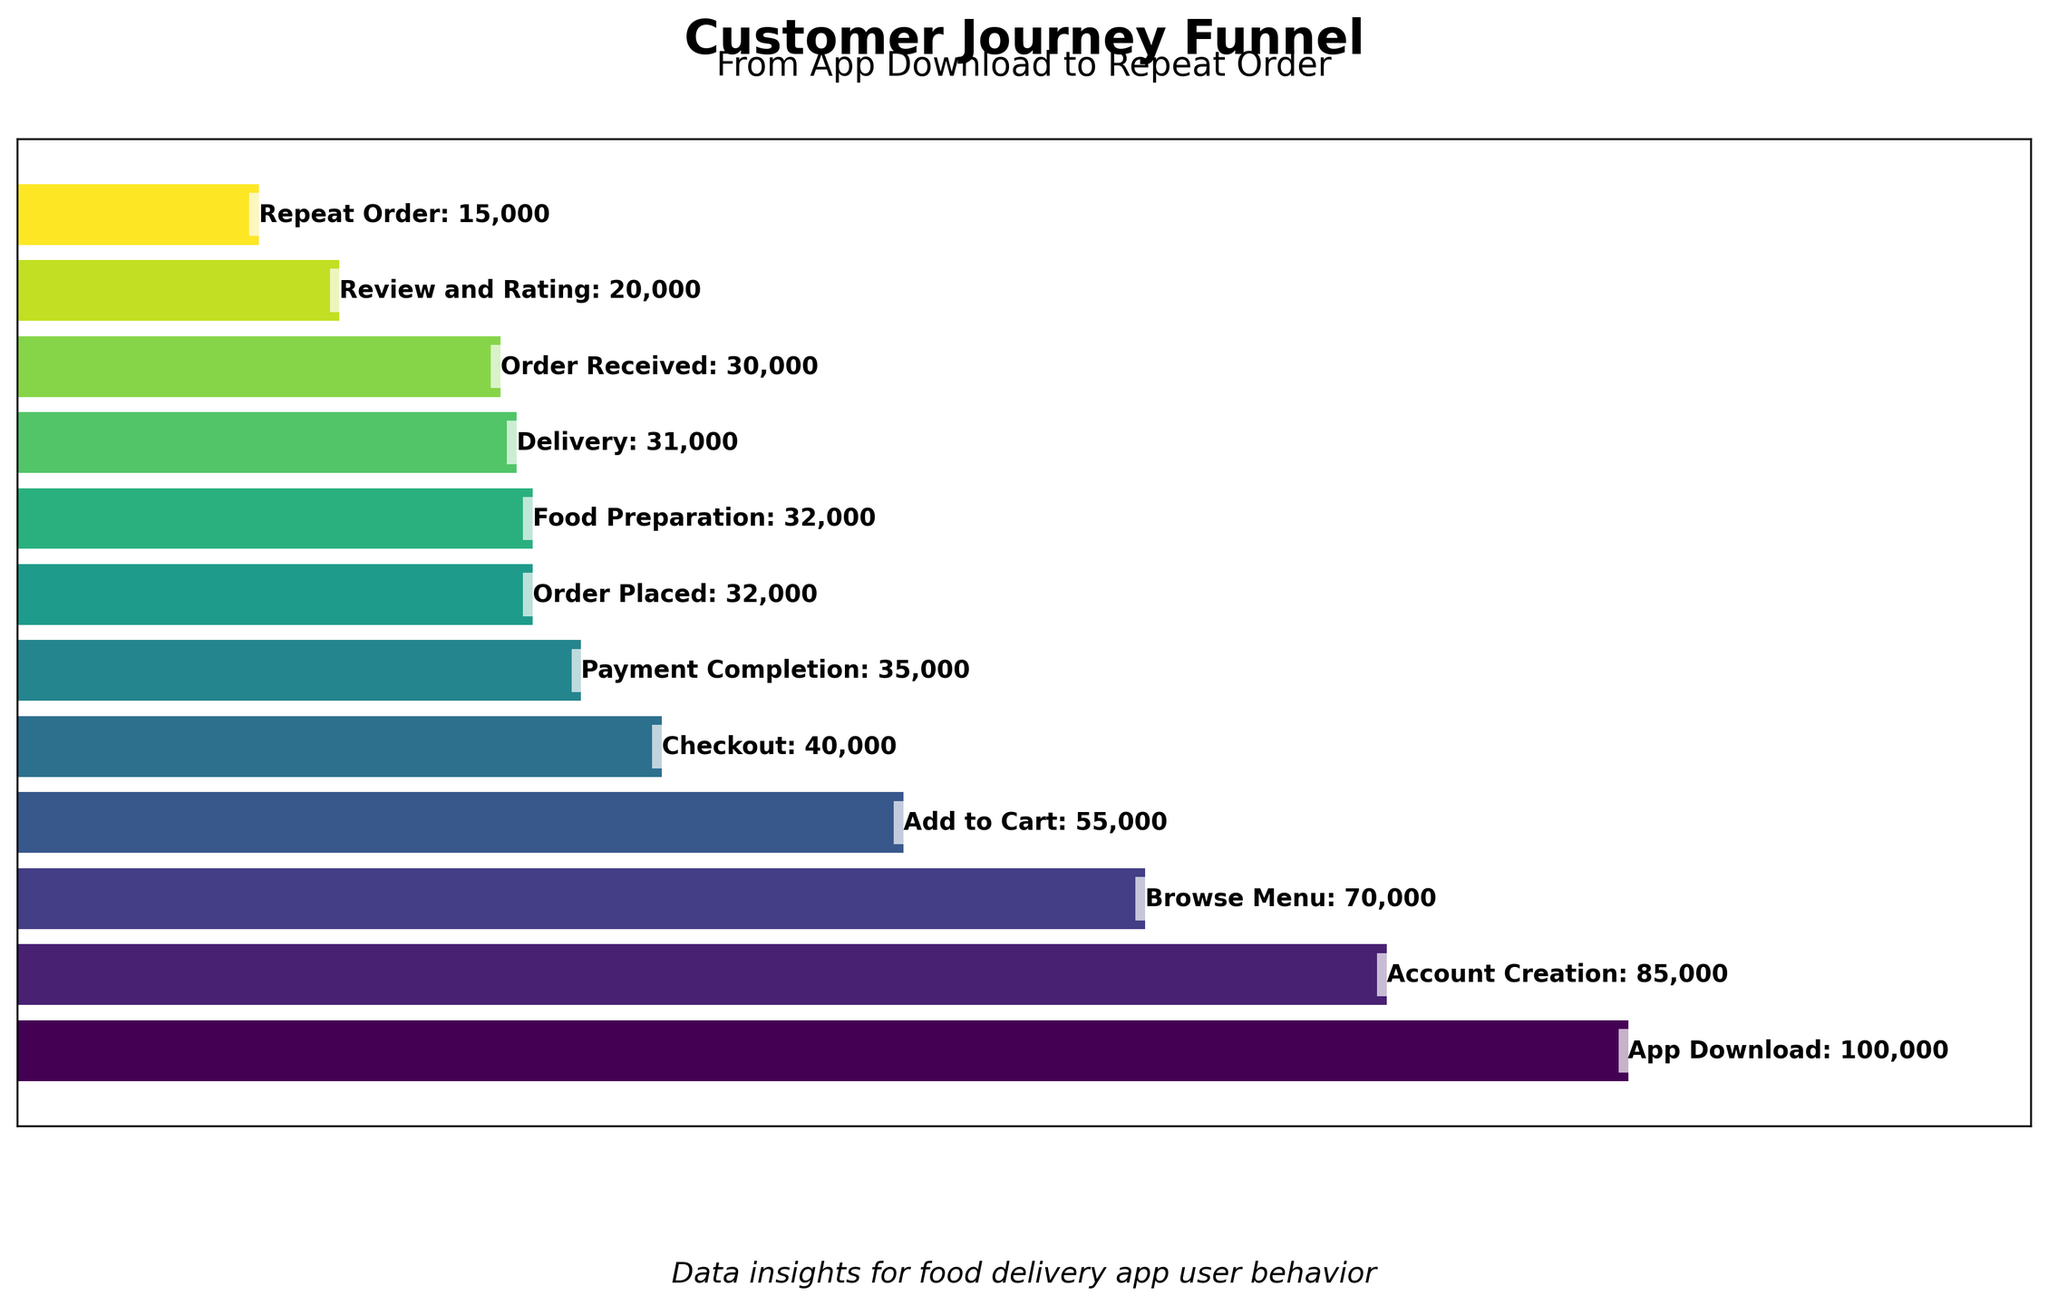Which stage has the highest number of users? The highest bar represents the stage with the largest number of users, which is the first stage "App Download" with 100,000 users.
Answer: App Download Which stage shows the greatest drop in user numbers compared to the previous stage? Comparing the user numbers between consecutive stages, the largest difference is between "App Download" (100,000) and "Account Creation" (85,000), with a reduction of 15,000 users.
Answer: Account Creation How many users completed the "Checkout" stage? The "Checkout" stage is labeled on the figure with 40,000 users.
Answer: 40,000 What is the user retention from "Order Placed" to "Delivery"? The number of users at "Order Placed" is 32,000 and at "Delivery" is 31,000. The retention is 31,000 / 32,000 = 0.96875, or approximately 97%.
Answer: 97% Of the stages shown, which has the least number of users? The shortest bar corresponds to the "Repeat Order" stage, with 15,000 users.
Answer: Repeat Order What percentage of users go from "Food Preparation" to "Review and Rating"? The number of users in "Food Preparation" is 32,000 and in "Review and Rating" is 20,000. The percentage is (20,000 / 32,000) * 100 = 62.5%.
Answer: 62.5% Compare the number of users who complete "Payment Completion" and those who complete "Order Received". Which is higher and by how much? "Payment Completion" has 35,000 users, while "Order Received" has 30,000 users. The difference is 35,000 - 30,000 = 5,000 users.
Answer: Payment Completion, 5,000 users How many stages have more than 50,000 users? By counting the stages with more than 50,000 users (App Download, Account Creation, Browse Menu, Add to Cart), the total is 4 stages.
Answer: 4 stages What is the difference between the number of users who "Add to Cart" and those who "Checkout"? The "Add to Cart" stage has 55,000 users, and the "Checkout" stage has 40,000 users. The difference is 55,000 - 40,000 = 15,000 users.
Answer: 15,000 users Is there any stage where the number of users remains the same as the previous stage? Comparing consecutive stages, "Order Placed" and "Food Preparation" both have 32,000 users, indicating no change.
Answer: Yes, between Order Placed and Food Preparation 